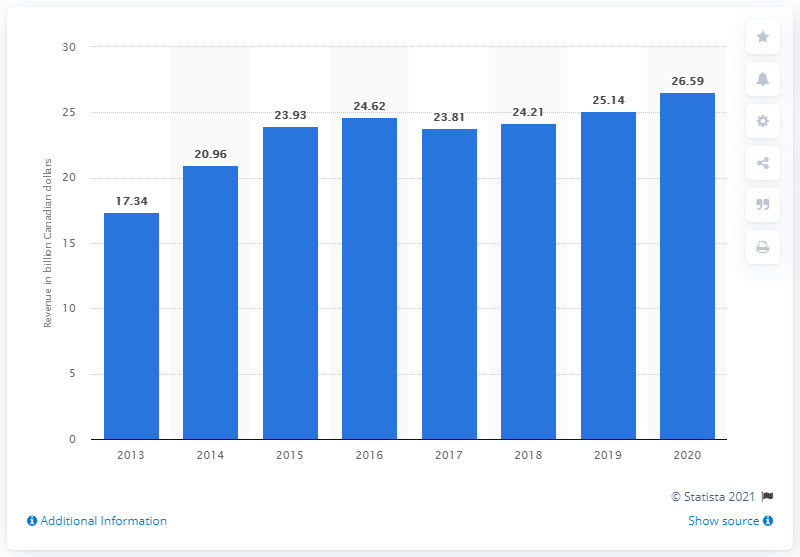Outline some significant characteristics in this image. The sales made by Empire Company Limited for the 52 weeks ended May 2, 2020, were 26.59 million dollars. 